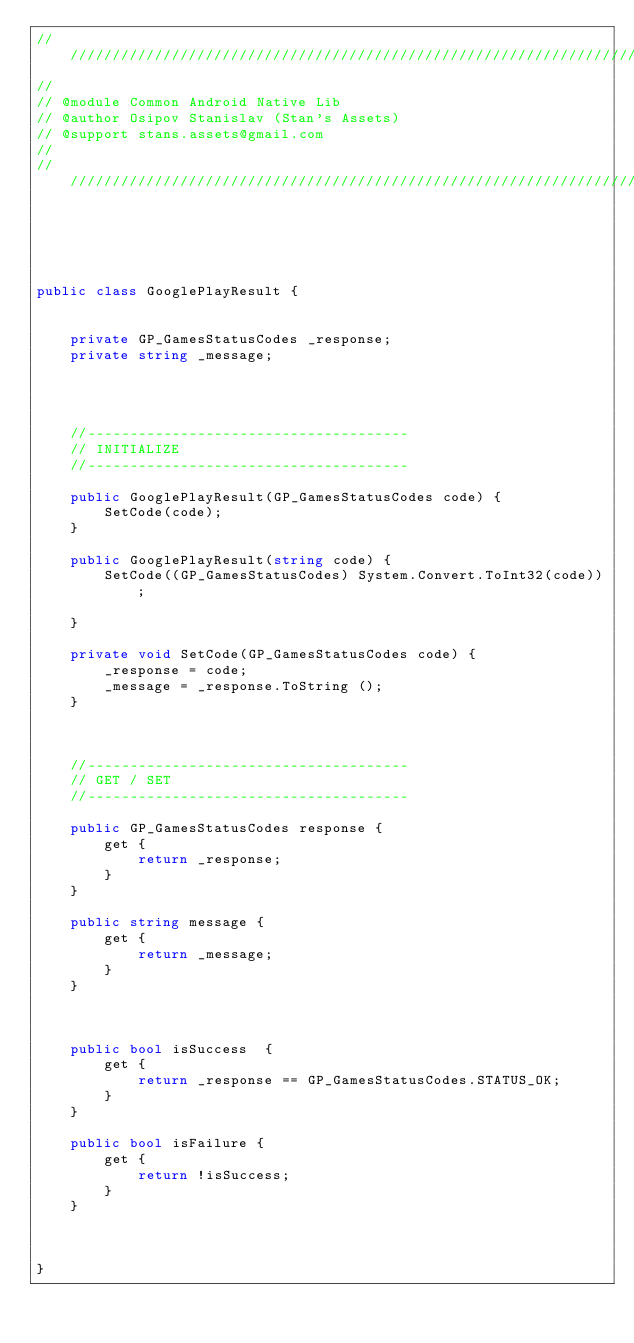Convert code to text. <code><loc_0><loc_0><loc_500><loc_500><_C#_>////////////////////////////////////////////////////////////////////////////////
//  
// @module Common Android Native Lib
// @author Osipov Stanislav (Stan's Assets) 
// @support stans.assets@gmail.com 
//
////////////////////////////////////////////////////////////////////////////////


 


public class GooglePlayResult {


	private GP_GamesStatusCodes _response;
	private string _message;




	//--------------------------------------
	// INITIALIZE
	//--------------------------------------

	public GooglePlayResult(GP_GamesStatusCodes code) {
		SetCode(code);
	}

	public GooglePlayResult(string code) {
		SetCode((GP_GamesStatusCodes) System.Convert.ToInt32(code));

	}

	private void SetCode(GP_GamesStatusCodes code) {
		_response = code;
		_message = _response.ToString ();
	}



	//--------------------------------------
	// GET / SET
	//--------------------------------------

	public GP_GamesStatusCodes response {
		get {
			return _response;
		}
	}

	public string message {
		get {
			return _message;
		}
	}



	public bool isSuccess  {
		get {
			return _response == GP_GamesStatusCodes.STATUS_OK;
		}
	}

	public bool isFailure {
		get {
			return !isSuccess;
		}
	}


		 
}</code> 